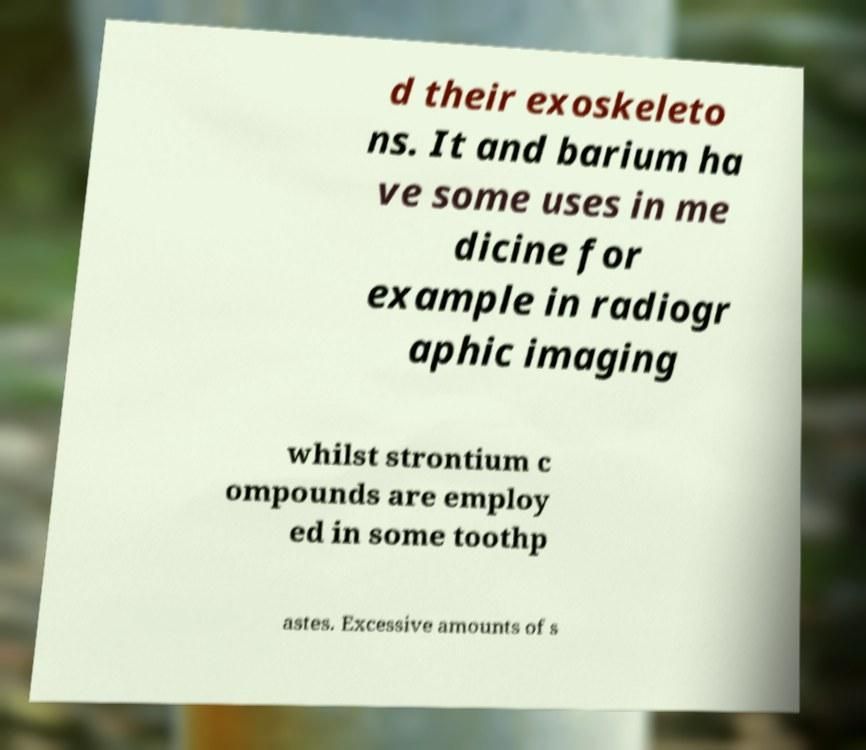Please identify and transcribe the text found in this image. d their exoskeleto ns. It and barium ha ve some uses in me dicine for example in radiogr aphic imaging whilst strontium c ompounds are employ ed in some toothp astes. Excessive amounts of s 